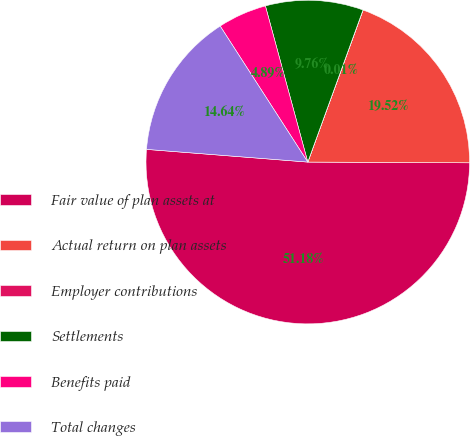<chart> <loc_0><loc_0><loc_500><loc_500><pie_chart><fcel>Fair value of plan assets at<fcel>Actual return on plan assets<fcel>Employer contributions<fcel>Settlements<fcel>Benefits paid<fcel>Total changes<nl><fcel>51.18%<fcel>19.52%<fcel>0.01%<fcel>9.76%<fcel>4.89%<fcel>14.64%<nl></chart> 